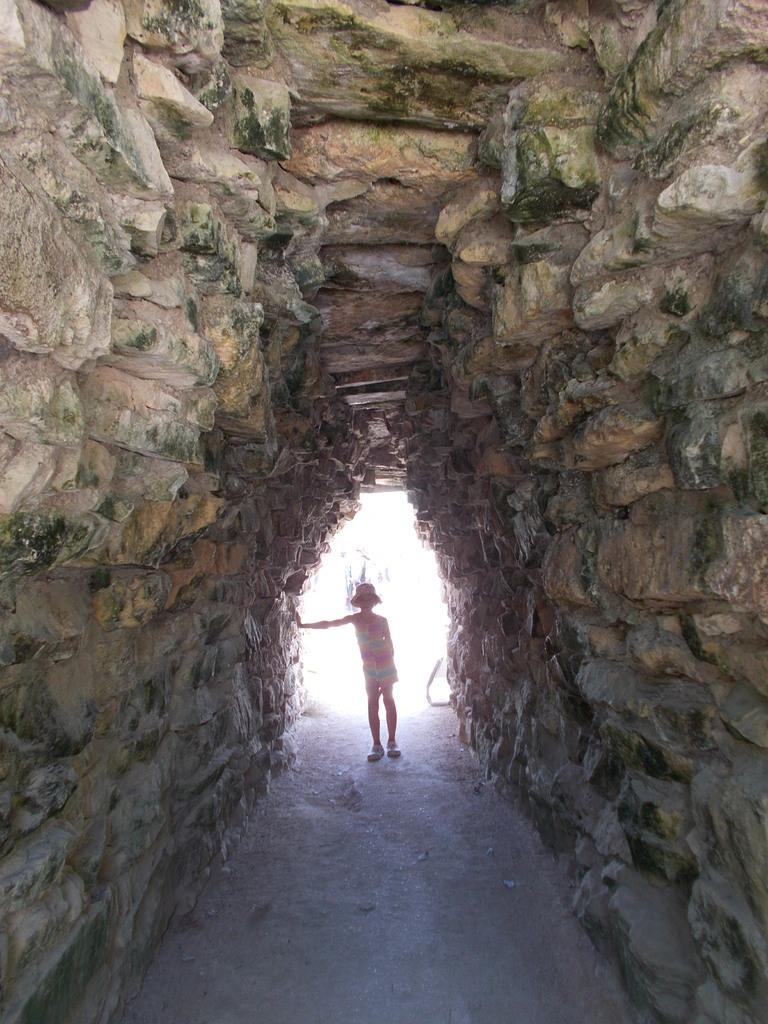Who is present in the image? There is a girl in the image. What is the girl's position in the image? The girl is standing on the ground. Where is the girl located in the image? The girl is in a cave. What is the girl wearing on her head? The girl is wearing a hat on her head. What type of feather can be seen on the girl's clothing in the image? There is no feather visible on the girl's clothing in the image. What is the girl doing with the tramp in the image? There is no tramp present in the image, so the girl cannot be interacting with one. 